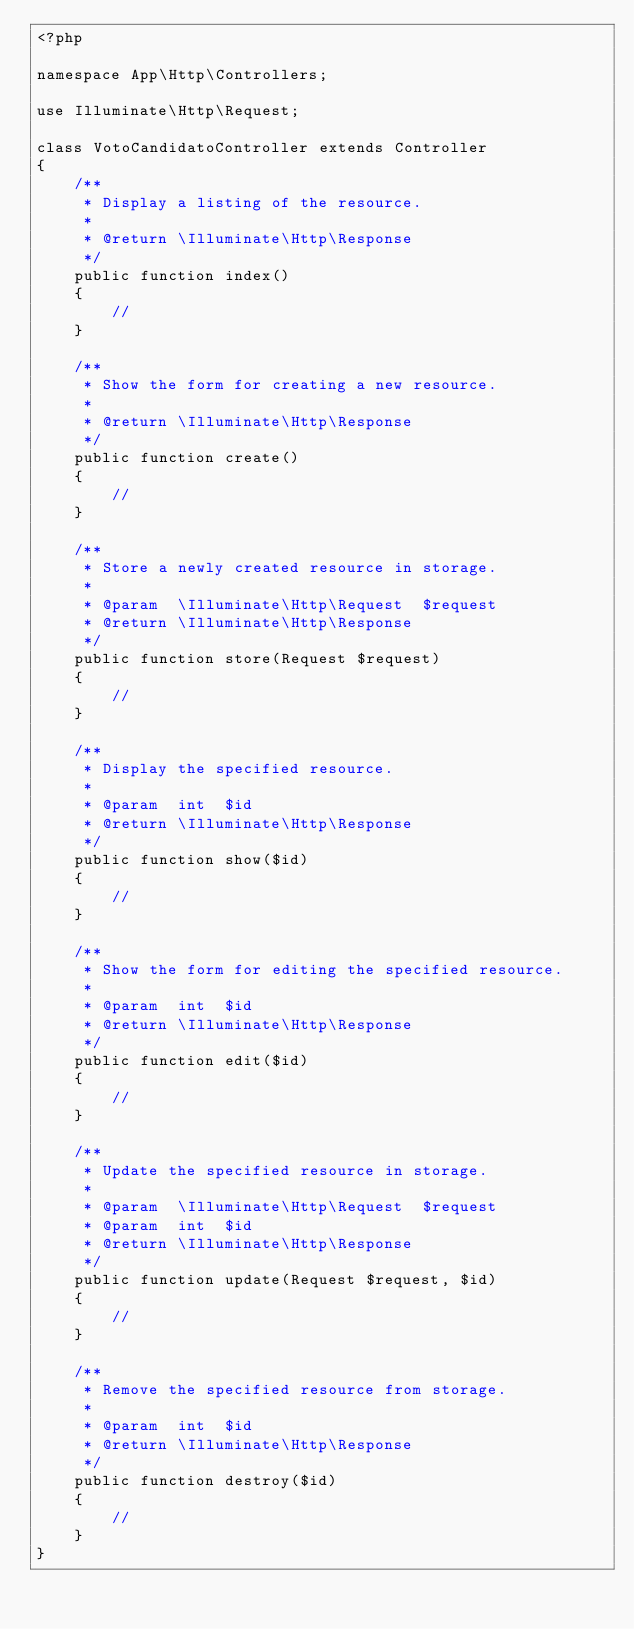<code> <loc_0><loc_0><loc_500><loc_500><_PHP_><?php

namespace App\Http\Controllers;

use Illuminate\Http\Request;

class VotoCandidatoController extends Controller
{
    /**
     * Display a listing of the resource.
     *
     * @return \Illuminate\Http\Response
     */
    public function index()
    {
        //
    }

    /**
     * Show the form for creating a new resource.
     *
     * @return \Illuminate\Http\Response
     */
    public function create()
    {
        //
    }

    /**
     * Store a newly created resource in storage.
     *
     * @param  \Illuminate\Http\Request  $request
     * @return \Illuminate\Http\Response
     */
    public function store(Request $request)
    {
        //
    }

    /**
     * Display the specified resource.
     *
     * @param  int  $id
     * @return \Illuminate\Http\Response
     */
    public function show($id)
    {
        //
    }

    /**
     * Show the form for editing the specified resource.
     *
     * @param  int  $id
     * @return \Illuminate\Http\Response
     */
    public function edit($id)
    {
        //
    }

    /**
     * Update the specified resource in storage.
     *
     * @param  \Illuminate\Http\Request  $request
     * @param  int  $id
     * @return \Illuminate\Http\Response
     */
    public function update(Request $request, $id)
    {
        //
    }

    /**
     * Remove the specified resource from storage.
     *
     * @param  int  $id
     * @return \Illuminate\Http\Response
     */
    public function destroy($id)
    {
        //
    }
}
</code> 